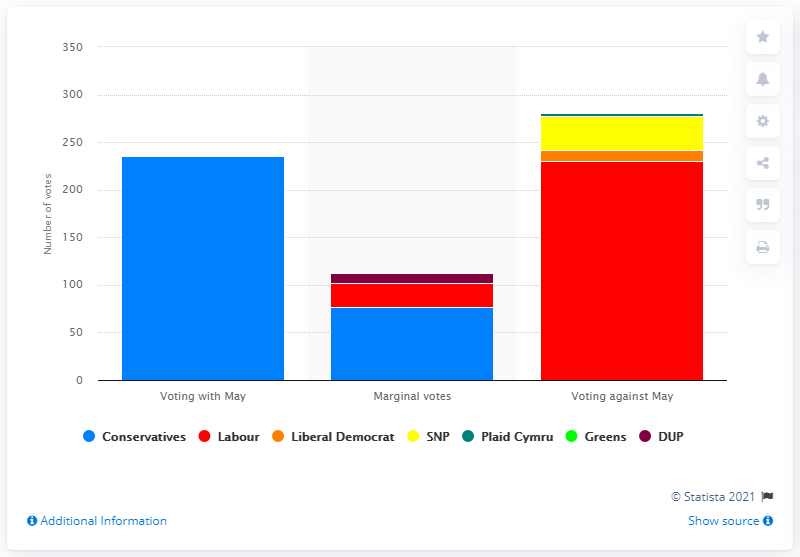Highlight a few significant elements in this photo. Seventy-seven other Conservative MPs have the ability to vote against Theresa May. As of my knowledge cutoff date, Theresa May had 235 loyal supporters in her parliamentary party who were committed to supporting her leadership and policies. 